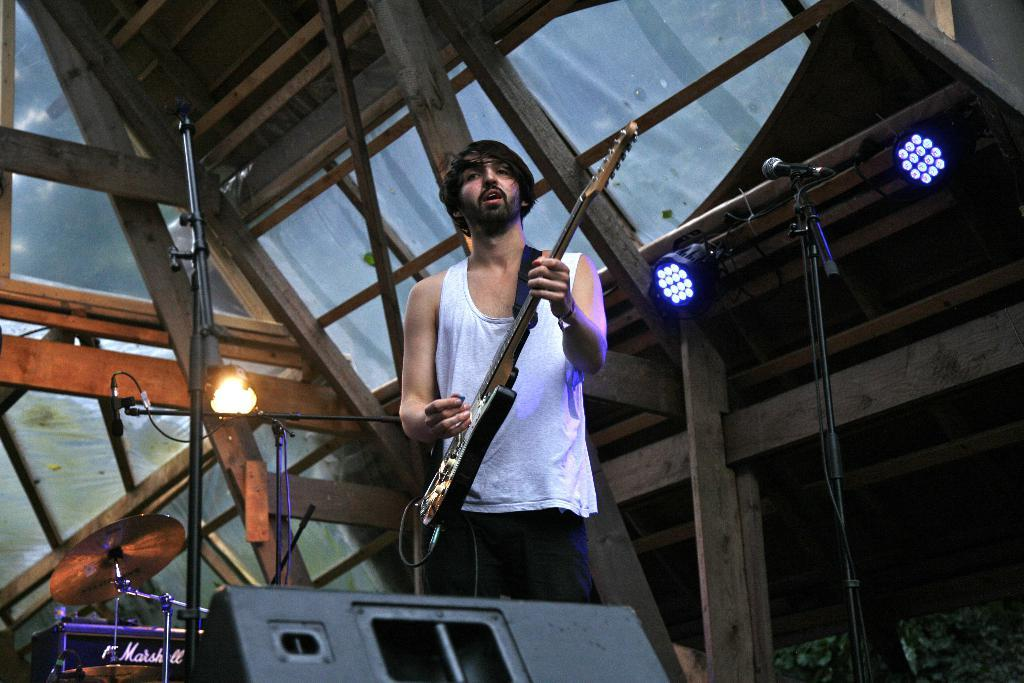What is the man in the image holding? The man is holding a guitar. What position is the man in? The man is standing. What objects are in front of the man? There are microphones in front of the man. What can be seen in the background of the image? There is a roof visible in the background of the image. What type of beast can be seen playing the guitar in the image? There is no beast present in the image; it features a man playing the guitar. What material is the guitar made of in the image? The material of the guitar is not mentioned in the image, so it cannot be determined. 